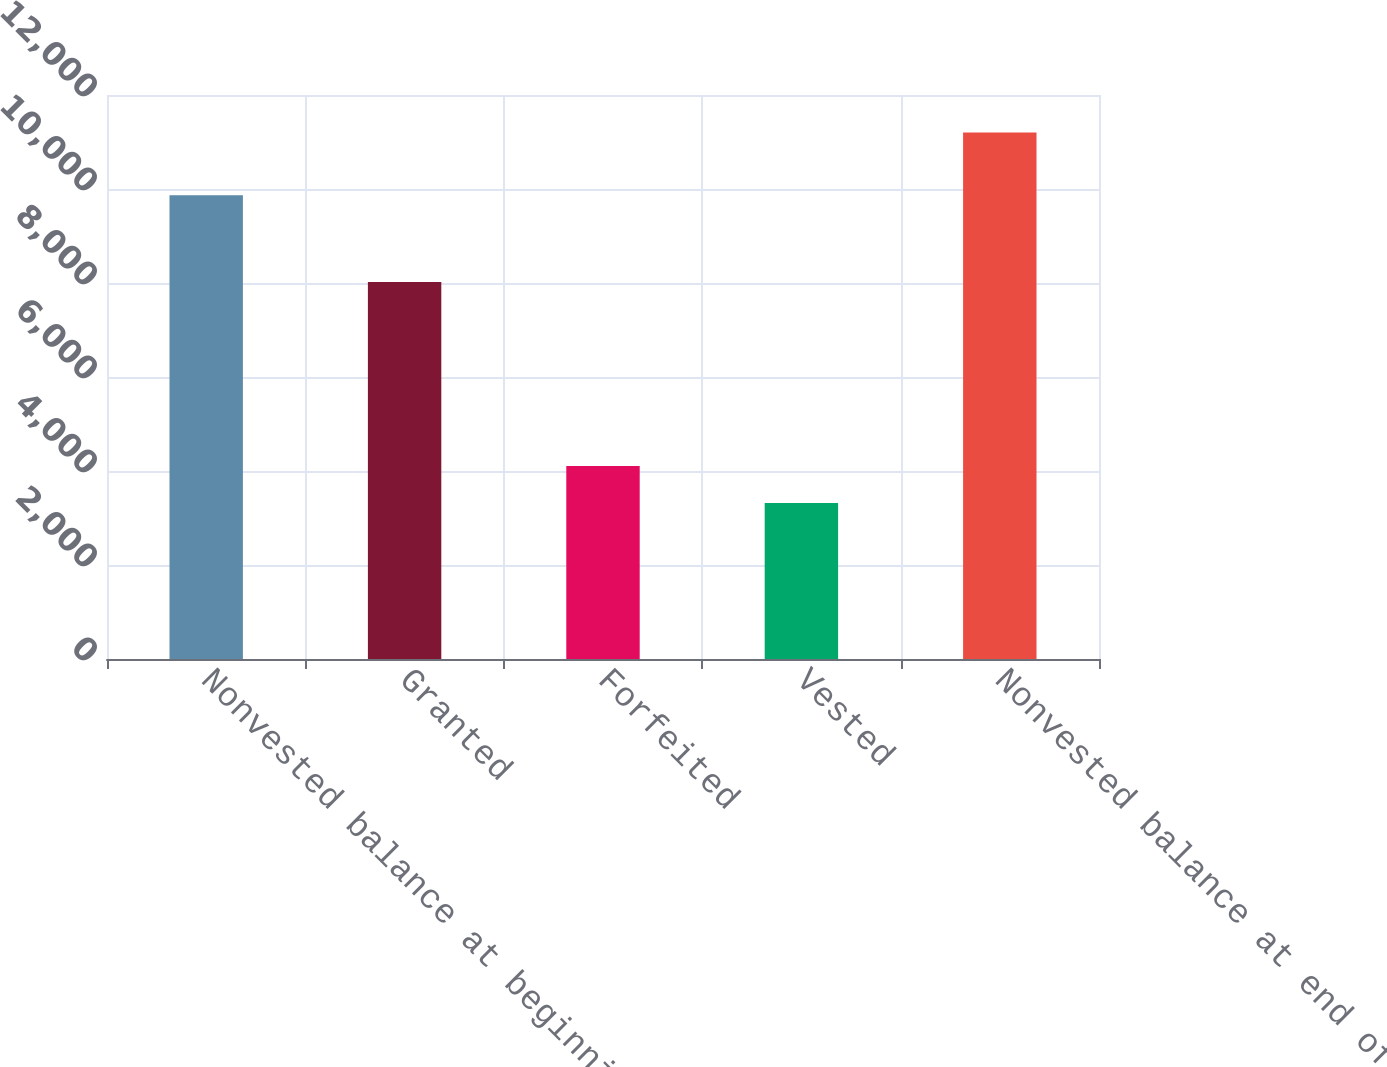Convert chart to OTSL. <chart><loc_0><loc_0><loc_500><loc_500><bar_chart><fcel>Nonvested balance at beginning<fcel>Granted<fcel>Forfeited<fcel>Vested<fcel>Nonvested balance at end of<nl><fcel>9867<fcel>8023<fcel>4108.2<fcel>3320<fcel>11202<nl></chart> 